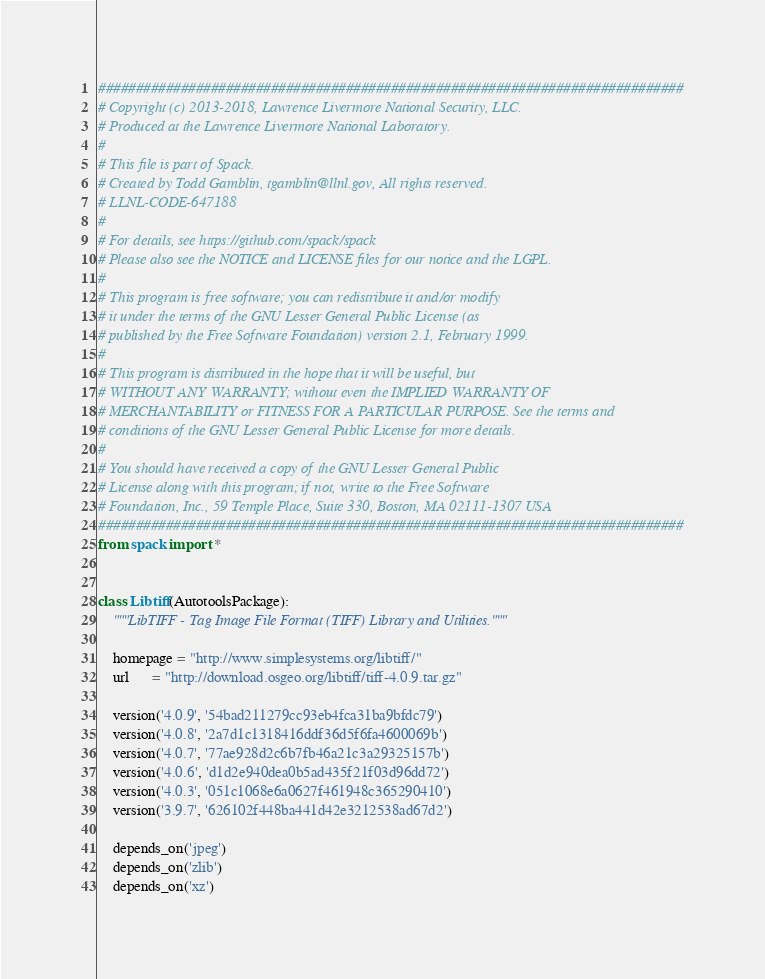<code> <loc_0><loc_0><loc_500><loc_500><_Python_>##############################################################################
# Copyright (c) 2013-2018, Lawrence Livermore National Security, LLC.
# Produced at the Lawrence Livermore National Laboratory.
#
# This file is part of Spack.
# Created by Todd Gamblin, tgamblin@llnl.gov, All rights reserved.
# LLNL-CODE-647188
#
# For details, see https://github.com/spack/spack
# Please also see the NOTICE and LICENSE files for our notice and the LGPL.
#
# This program is free software; you can redistribute it and/or modify
# it under the terms of the GNU Lesser General Public License (as
# published by the Free Software Foundation) version 2.1, February 1999.
#
# This program is distributed in the hope that it will be useful, but
# WITHOUT ANY WARRANTY; without even the IMPLIED WARRANTY OF
# MERCHANTABILITY or FITNESS FOR A PARTICULAR PURPOSE. See the terms and
# conditions of the GNU Lesser General Public License for more details.
#
# You should have received a copy of the GNU Lesser General Public
# License along with this program; if not, write to the Free Software
# Foundation, Inc., 59 Temple Place, Suite 330, Boston, MA 02111-1307 USA
##############################################################################
from spack import *


class Libtiff(AutotoolsPackage):
    """LibTIFF - Tag Image File Format (TIFF) Library and Utilities."""

    homepage = "http://www.simplesystems.org/libtiff/"
    url      = "http://download.osgeo.org/libtiff/tiff-4.0.9.tar.gz"

    version('4.0.9', '54bad211279cc93eb4fca31ba9bfdc79')
    version('4.0.8', '2a7d1c1318416ddf36d5f6fa4600069b')
    version('4.0.7', '77ae928d2c6b7fb46a21c3a29325157b')
    version('4.0.6', 'd1d2e940dea0b5ad435f21f03d96dd72')
    version('4.0.3', '051c1068e6a0627f461948c365290410')
    version('3.9.7', '626102f448ba441d42e3212538ad67d2')

    depends_on('jpeg')
    depends_on('zlib')
    depends_on('xz')
</code> 